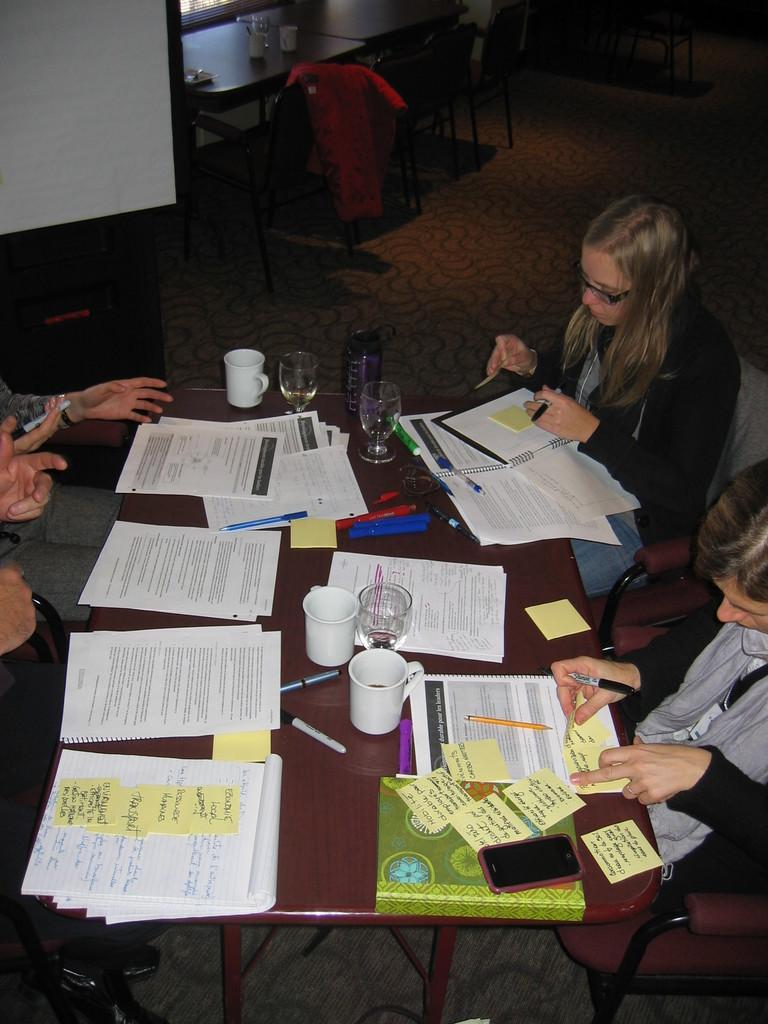What are the people in the image doing? There is a group of people sitting at a table in the image. What items can be seen on the table? There are paper items, cups, glasses, pens, and a phone on the table. What is located at the back of the room? At the back of the room, there is a screen and a table with chairs. How many legs does the kitty have in the image? There is no kitty present in the image, so it is not possible to determine the number of legs it might have. 